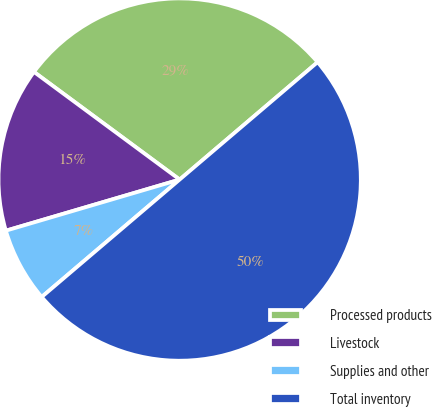Convert chart to OTSL. <chart><loc_0><loc_0><loc_500><loc_500><pie_chart><fcel>Processed products<fcel>Livestock<fcel>Supplies and other<fcel>Total inventory<nl><fcel>28.65%<fcel>14.68%<fcel>6.67%<fcel>50.0%<nl></chart> 